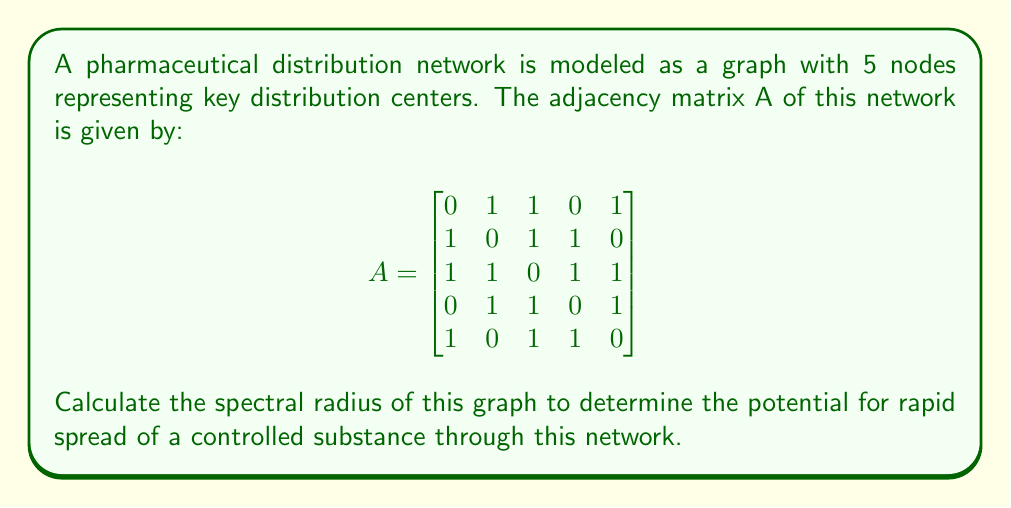Can you answer this question? To find the spectral radius of the graph, we need to follow these steps:

1) The spectral radius is the largest absolute eigenvalue of the adjacency matrix A.

2) To find the eigenvalues, we need to solve the characteristic equation:
   $\det(A - \lambda I) = 0$

3) Expanding this determinant:
   $$\begin{vmatrix}
   -\lambda & 1 & 1 & 0 & 1 \\
   1 & -\lambda & 1 & 1 & 0 \\
   1 & 1 & -\lambda & 1 & 1 \\
   0 & 1 & 1 & -\lambda & 1 \\
   1 & 0 & 1 & 1 & -\lambda
   \end{vmatrix} = 0$$

4) This expands to the characteristic polynomial:
   $\lambda^5 - 10\lambda^3 - 8\lambda^2 + 5\lambda + 4 = 0$

5) Using a computer algebra system or numerical methods, we find the roots of this polynomial:
   $\lambda_1 \approx 2.7775$
   $\lambda_2 \approx -1.7775$
   $\lambda_3 \approx 1.1723$
   $\lambda_4 \approx -1.1723$
   $\lambda_5 = 0$

6) The spectral radius is the largest absolute value among these eigenvalues, which is $\lambda_1 \approx 2.7775$.

This high spectral radius indicates a strong potential for rapid spread through the network, which could be concerning for controlled substance distribution.
Answer: $2.7775$ 